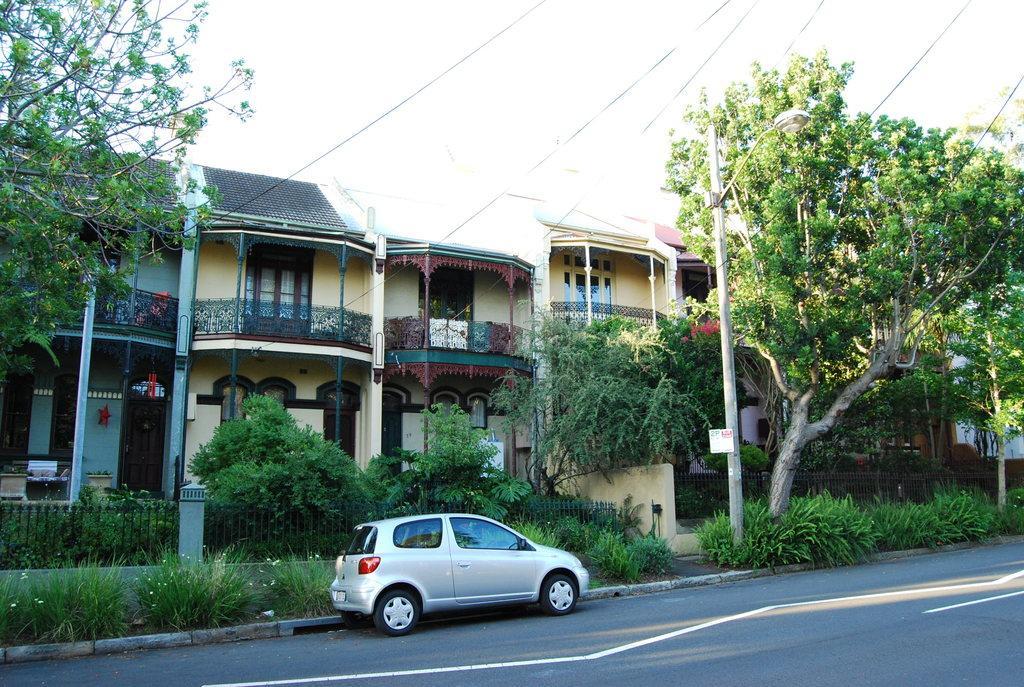Describe this image in one or two sentences. In this picture we can see a car on the road and in the background we can see buildings,trees,sky. 